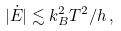Convert formula to latex. <formula><loc_0><loc_0><loc_500><loc_500>| \dot { E } | \lesssim k _ { B } ^ { 2 } T ^ { 2 } / h \, ,</formula> 